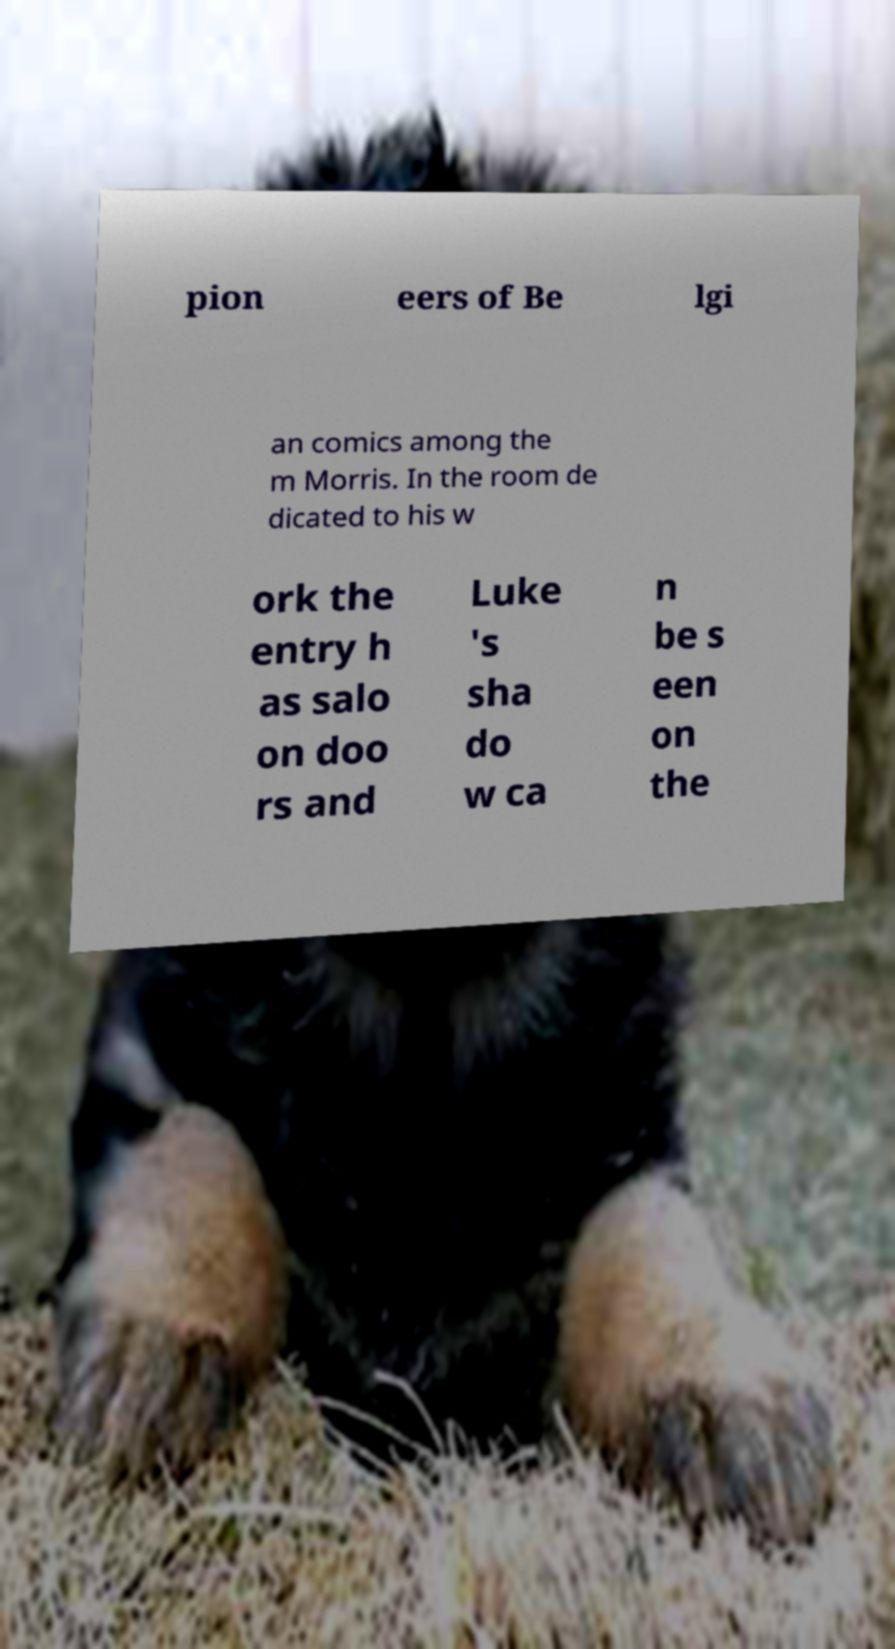Can you accurately transcribe the text from the provided image for me? pion eers of Be lgi an comics among the m Morris. In the room de dicated to his w ork the entry h as salo on doo rs and Luke 's sha do w ca n be s een on the 